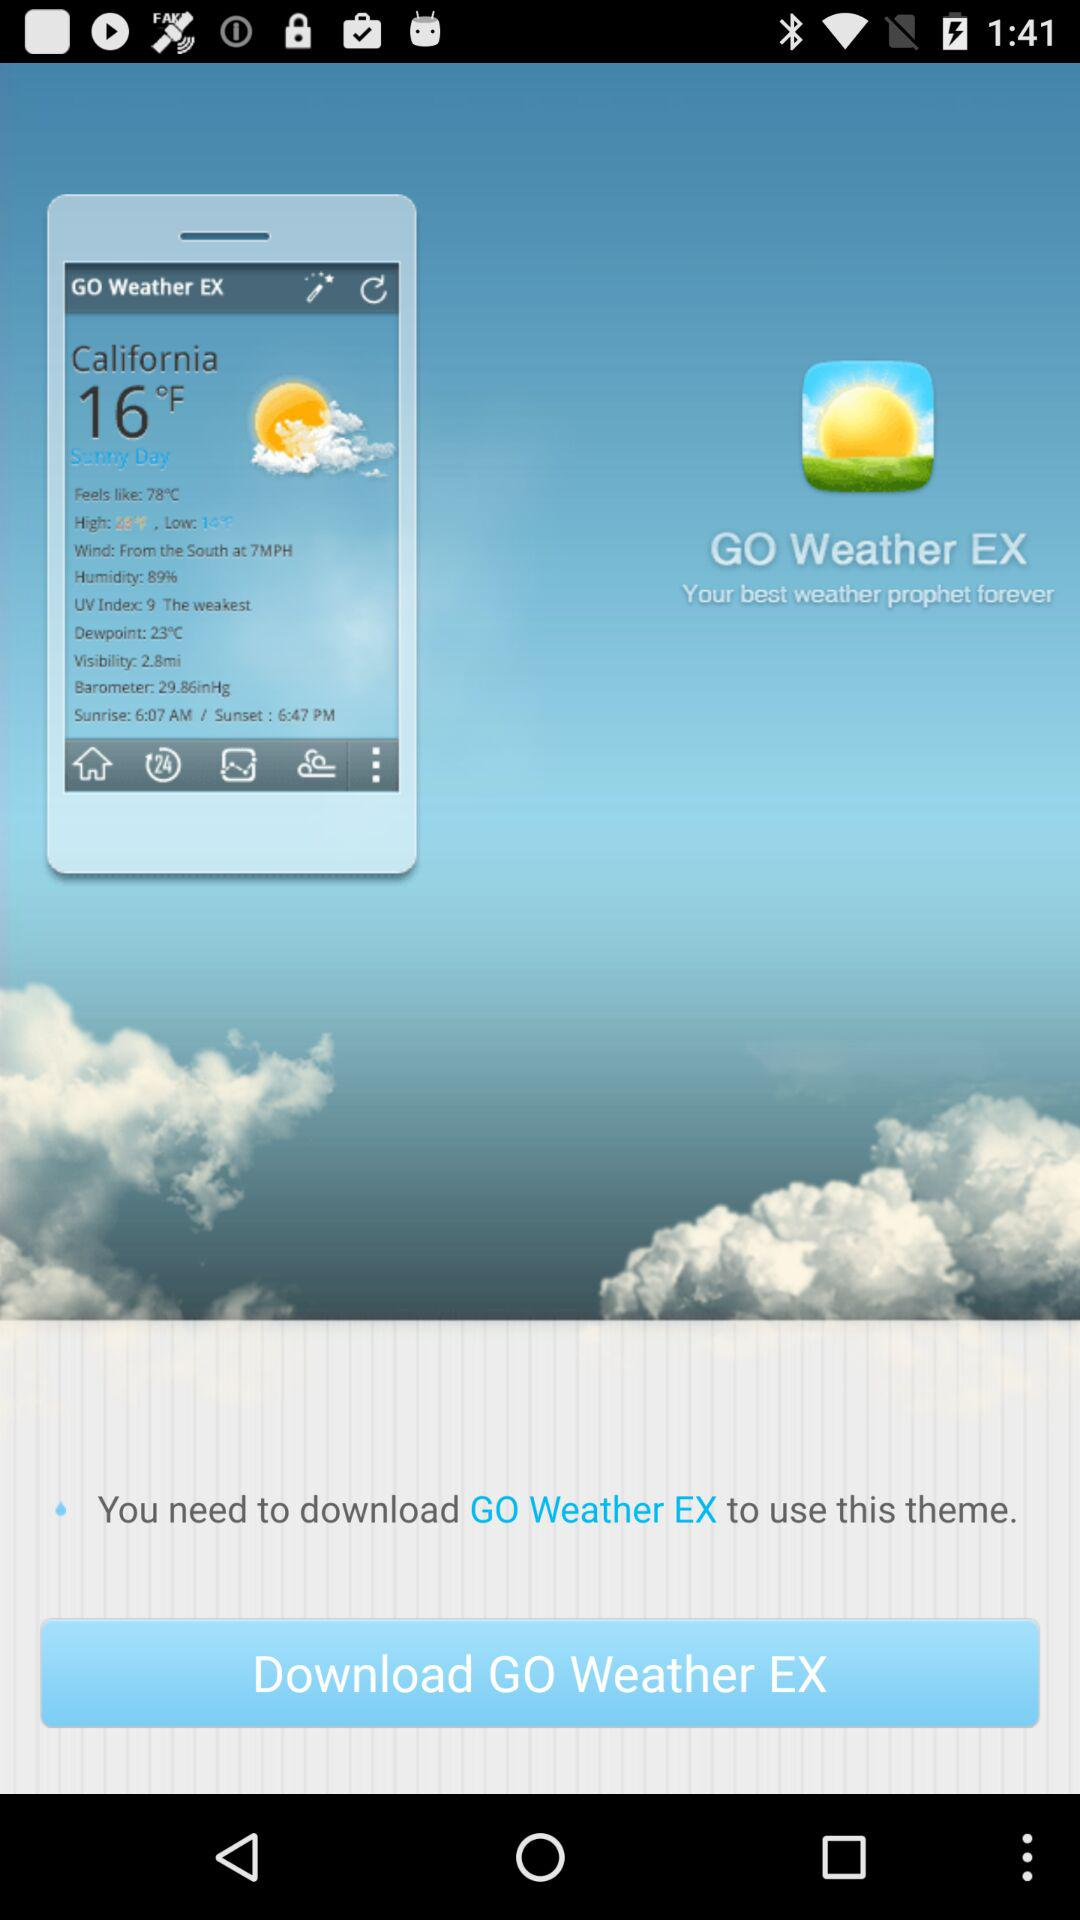What is the name of the theme that can be used?
When the provided information is insufficient, respond with <no answer>. <no answer> 